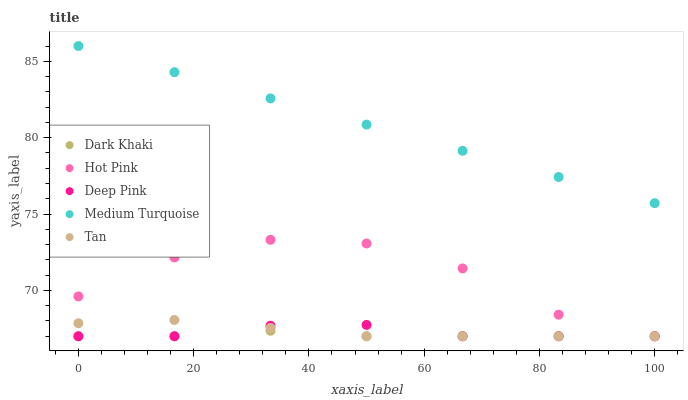Does Dark Khaki have the minimum area under the curve?
Answer yes or no. Yes. Does Medium Turquoise have the maximum area under the curve?
Answer yes or no. Yes. Does Tan have the minimum area under the curve?
Answer yes or no. No. Does Tan have the maximum area under the curve?
Answer yes or no. No. Is Medium Turquoise the smoothest?
Answer yes or no. Yes. Is Hot Pink the roughest?
Answer yes or no. Yes. Is Tan the smoothest?
Answer yes or no. No. Is Tan the roughest?
Answer yes or no. No. Does Dark Khaki have the lowest value?
Answer yes or no. Yes. Does Medium Turquoise have the lowest value?
Answer yes or no. No. Does Medium Turquoise have the highest value?
Answer yes or no. Yes. Does Tan have the highest value?
Answer yes or no. No. Is Tan less than Medium Turquoise?
Answer yes or no. Yes. Is Medium Turquoise greater than Hot Pink?
Answer yes or no. Yes. Does Hot Pink intersect Dark Khaki?
Answer yes or no. Yes. Is Hot Pink less than Dark Khaki?
Answer yes or no. No. Is Hot Pink greater than Dark Khaki?
Answer yes or no. No. Does Tan intersect Medium Turquoise?
Answer yes or no. No. 